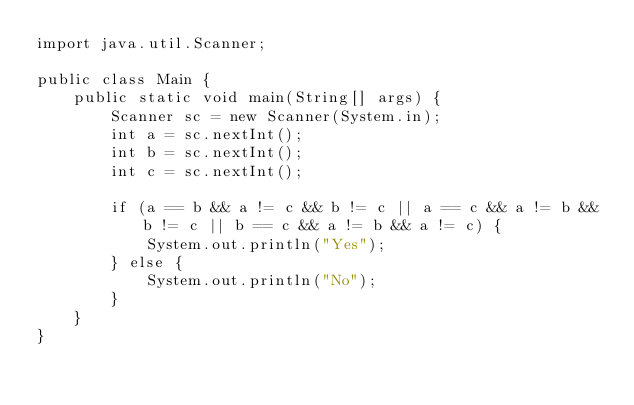<code> <loc_0><loc_0><loc_500><loc_500><_Java_>import java.util.Scanner;

public class Main {
    public static void main(String[] args) {
        Scanner sc = new Scanner(System.in);
        int a = sc.nextInt();
        int b = sc.nextInt();
        int c = sc.nextInt();

        if (a == b && a != c && b != c || a == c && a != b && b != c || b == c && a != b && a != c) {
            System.out.println("Yes");
        } else {
            System.out.println("No");
        }
    }
}
</code> 